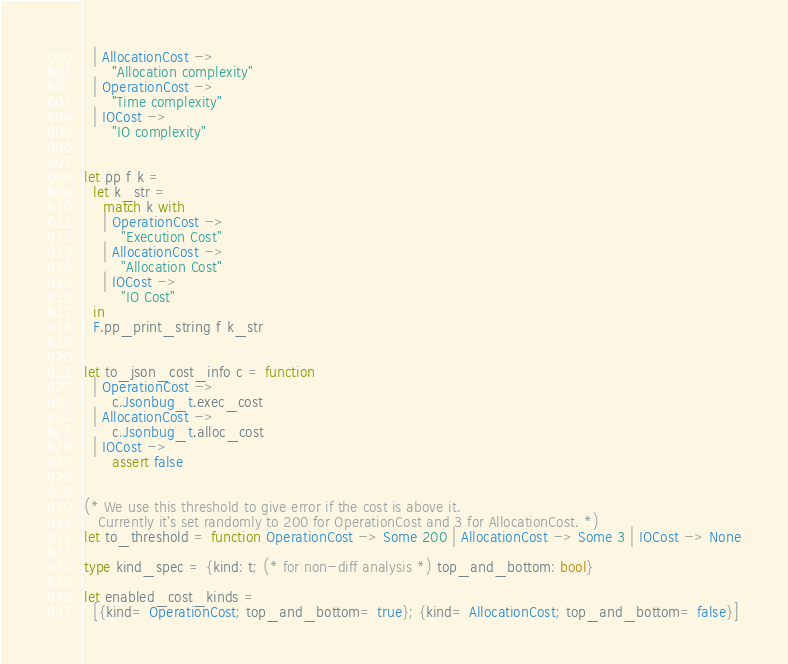<code> <loc_0><loc_0><loc_500><loc_500><_OCaml_>  | AllocationCost ->
      "Allocation complexity"
  | OperationCost ->
      "Time complexity"
  | IOCost ->
      "IO complexity"


let pp f k =
  let k_str =
    match k with
    | OperationCost ->
        "Execution Cost"
    | AllocationCost ->
        "Allocation Cost"
    | IOCost ->
        "IO Cost"
  in
  F.pp_print_string f k_str


let to_json_cost_info c = function
  | OperationCost ->
      c.Jsonbug_t.exec_cost
  | AllocationCost ->
      c.Jsonbug_t.alloc_cost
  | IOCost ->
      assert false


(* We use this threshold to give error if the cost is above it.
   Currently it's set randomly to 200 for OperationCost and 3 for AllocationCost. *)
let to_threshold = function OperationCost -> Some 200 | AllocationCost -> Some 3 | IOCost -> None

type kind_spec = {kind: t; (* for non-diff analysis *) top_and_bottom: bool}

let enabled_cost_kinds =
  [{kind= OperationCost; top_and_bottom= true}; {kind= AllocationCost; top_and_bottom= false}]
</code> 